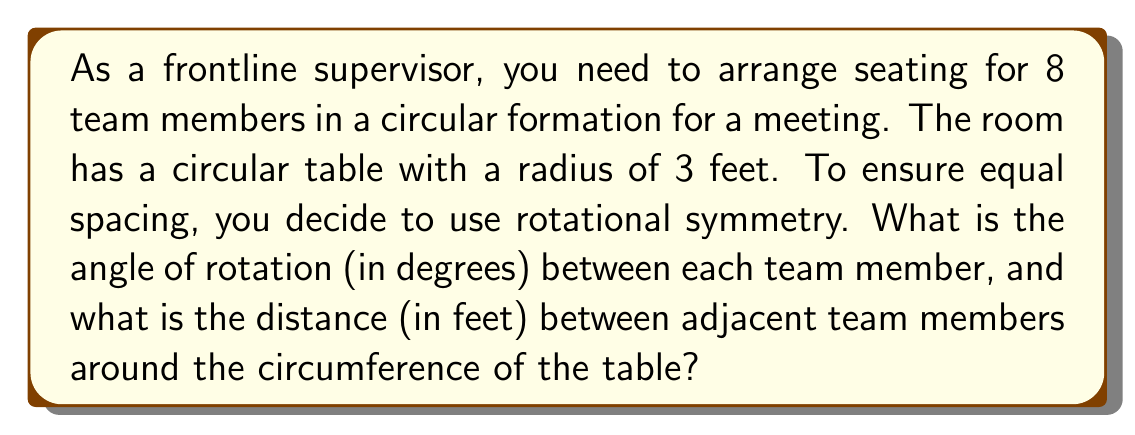Give your solution to this math problem. Let's approach this step-by-step:

1) For rotational symmetry with 8 team members, we need to divide the full circle (360°) into 8 equal parts.

   Angle of rotation = $\frac{360°}{8} = 45°$

2) To find the distance between adjacent team members, we need to calculate the circumference of the table and divide it by 8.

   Circumference = $2\pi r$, where $r$ is the radius
   
   Circumference = $2\pi(3) = 6\pi$ feet

3) Distance between adjacent members = $\frac{\text{Circumference}}{8} = \frac{6\pi}{8} = \frac{3\pi}{4}$ feet

4) To simplify:
   $\frac{3\pi}{4} \approx 2.356$ feet

Therefore, the angle of rotation is 45°, and the distance between adjacent team members is approximately 2.356 feet.

[asy]
import geometry;

size(200);
circle c = circle((0,0), 3);
draw(c);

for(int i = 0; i < 8; ++i) {
  real angle = i * 45 * pi / 180;
  dot((3*cos(angle), 3*sin(angle)));
}

draw((-3.5,0)--(3.5,0), arrow=Arrow(TeXHead));
draw((0,-3.5)--(0,3.5), arrow=Arrow(TeXHead));

label("3 ft", (1.5,0), S);
[/asy]
Answer: 45°, $\frac{3\pi}{4}$ feet 